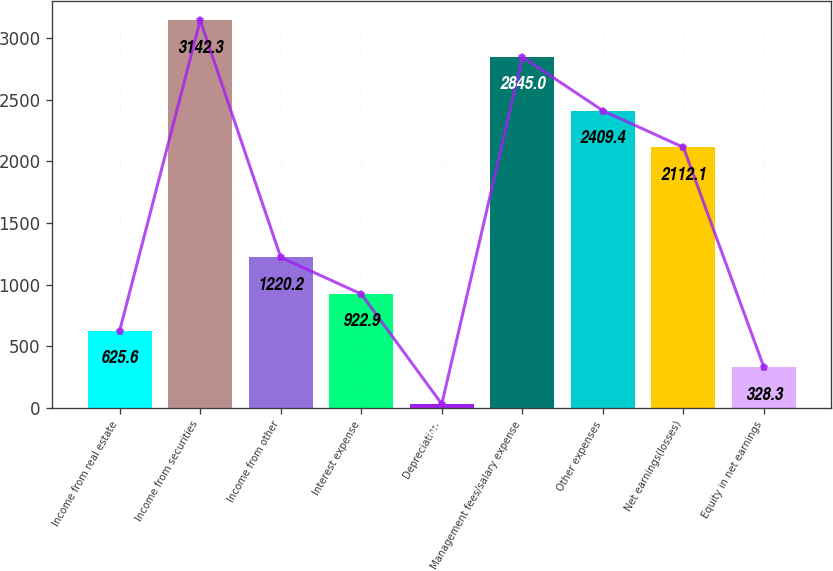Convert chart to OTSL. <chart><loc_0><loc_0><loc_500><loc_500><bar_chart><fcel>Income from real estate<fcel>Income from securities<fcel>Income from other<fcel>Interest expense<fcel>Depreciation<fcel>Management fees/salary expense<fcel>Other expenses<fcel>Net earnings(losses)<fcel>Equity in net earnings<nl><fcel>625.6<fcel>3142.3<fcel>1220.2<fcel>922.9<fcel>31<fcel>2845<fcel>2409.4<fcel>2112.1<fcel>328.3<nl></chart> 